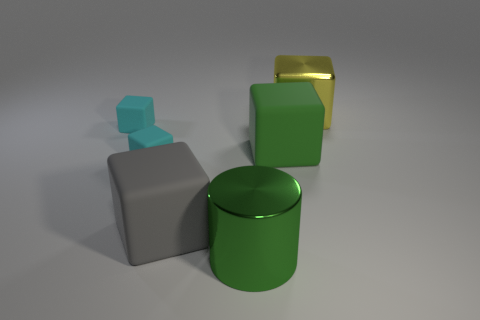There is a metallic thing that is in front of the gray matte block; does it have the same color as the matte thing to the right of the large gray rubber cube?
Offer a terse response. Yes. Is the color of the rubber block right of the big gray block the same as the big cylinder?
Your answer should be very brief. Yes. There is a metal object on the right side of the metal thing to the left of the big metallic block; is there a metallic object that is behind it?
Your answer should be compact. No. How many other objects are there of the same shape as the yellow metal thing?
Provide a short and direct response. 4. What shape is the large thing that is both behind the large gray matte thing and in front of the metal block?
Your response must be concise. Cube. What color is the matte object right of the large rubber thing that is to the left of the shiny thing to the left of the yellow shiny object?
Offer a very short reply. Green. Is the number of large gray cubes that are behind the big gray matte thing greater than the number of big green rubber objects right of the green matte thing?
Keep it short and to the point. No. There is a object that is the same color as the cylinder; what size is it?
Provide a succinct answer. Large. What is the green object to the right of the metallic object in front of the yellow thing made of?
Your answer should be very brief. Rubber. There is a large yellow block; are there any cyan cubes to the left of it?
Your response must be concise. Yes. 